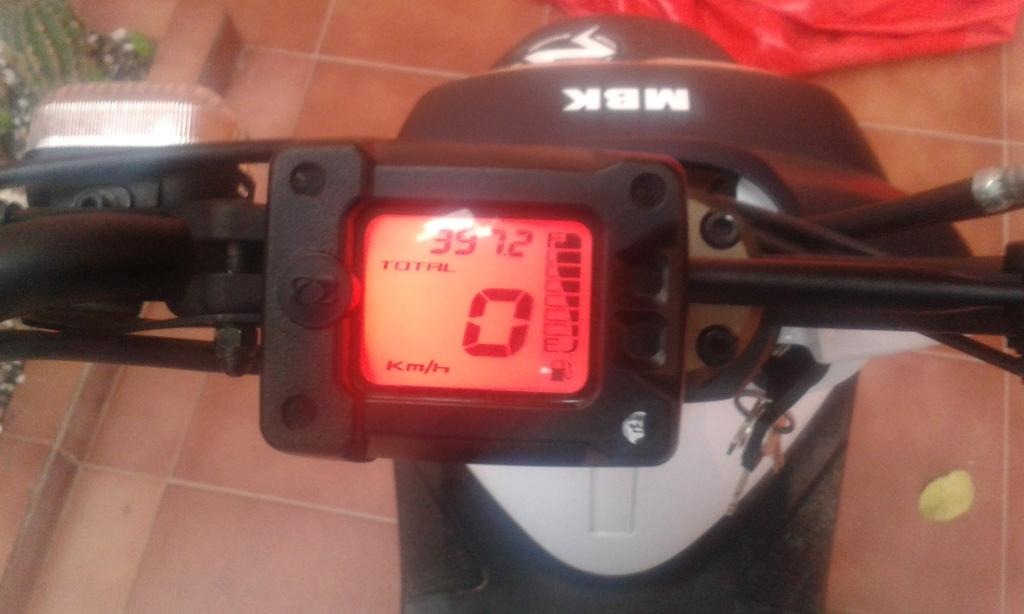What type of vehicle does the speedometer in the picture belong to? The speedometer belongs to a bike. What feature can be seen on the left side of the speedometer? There is an indicator in the left corner of the speedometer. What object is located in the right corner of the picture? There are keys in the right corner of the picture. How does the goldfish contribute to the digestion process in the image? There is no goldfish or digestion process present in the image. 